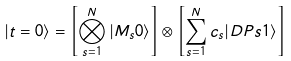Convert formula to latex. <formula><loc_0><loc_0><loc_500><loc_500>| t = 0 \rangle = \left [ \bigotimes _ { s = 1 } ^ { N } | M _ { s } 0 \rangle \right ] \otimes \left [ \sum _ { s = 1 } ^ { N } c _ { s } | D P s 1 \rangle \right ]</formula> 